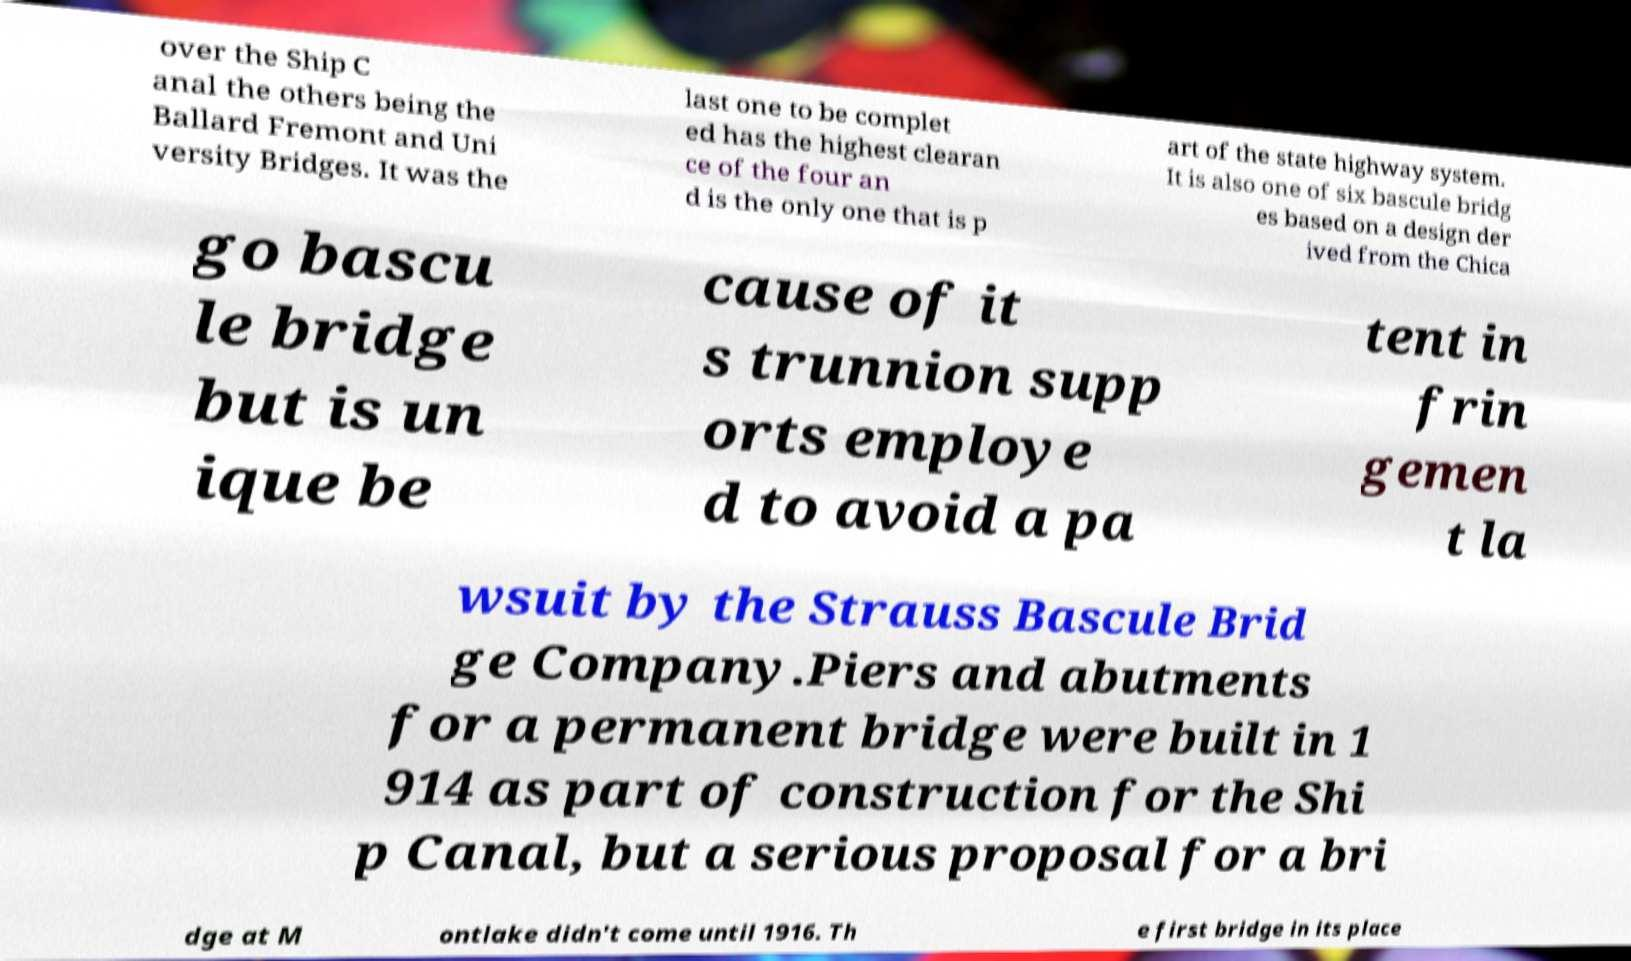I need the written content from this picture converted into text. Can you do that? over the Ship C anal the others being the Ballard Fremont and Uni versity Bridges. It was the last one to be complet ed has the highest clearan ce of the four an d is the only one that is p art of the state highway system. It is also one of six bascule bridg es based on a design der ived from the Chica go bascu le bridge but is un ique be cause of it s trunnion supp orts employe d to avoid a pa tent in frin gemen t la wsuit by the Strauss Bascule Brid ge Company.Piers and abutments for a permanent bridge were built in 1 914 as part of construction for the Shi p Canal, but a serious proposal for a bri dge at M ontlake didn't come until 1916. Th e first bridge in its place 